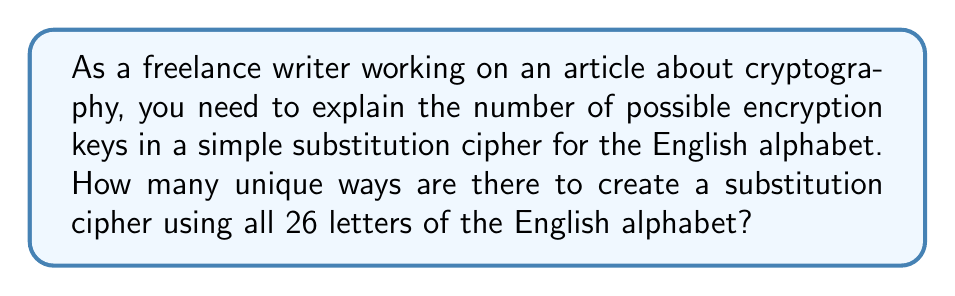Can you answer this question? To solve this problem, let's break it down step-by-step:

1. In a simple substitution cipher, each letter of the alphabet is replaced by another letter.

2. We need to count how many ways we can arrange 26 letters to create a unique cipher.

3. This is a permutation problem, as the order matters and we're using all 26 letters.

4. The number of permutations of n distinct objects is given by the factorial of n, denoted as n!

5. In this case, n = 26 (the number of letters in the English alphabet)

6. Therefore, the number of possible encryption keys is:

   $$26! = 26 \times 25 \times 24 \times ... \times 3 \times 2 \times 1$$

7. Calculating this out:
   
   $$26! = 403,291,461,126,605,635,584,000,000$$

8. This number is approximately $4.03 \times 10^{26}$

This enormous number of possibilities is what makes simple substitution ciphers difficult to break by brute force, despite their simplicity.
Answer: $26! \approx 4.03 \times 10^{26}$ 